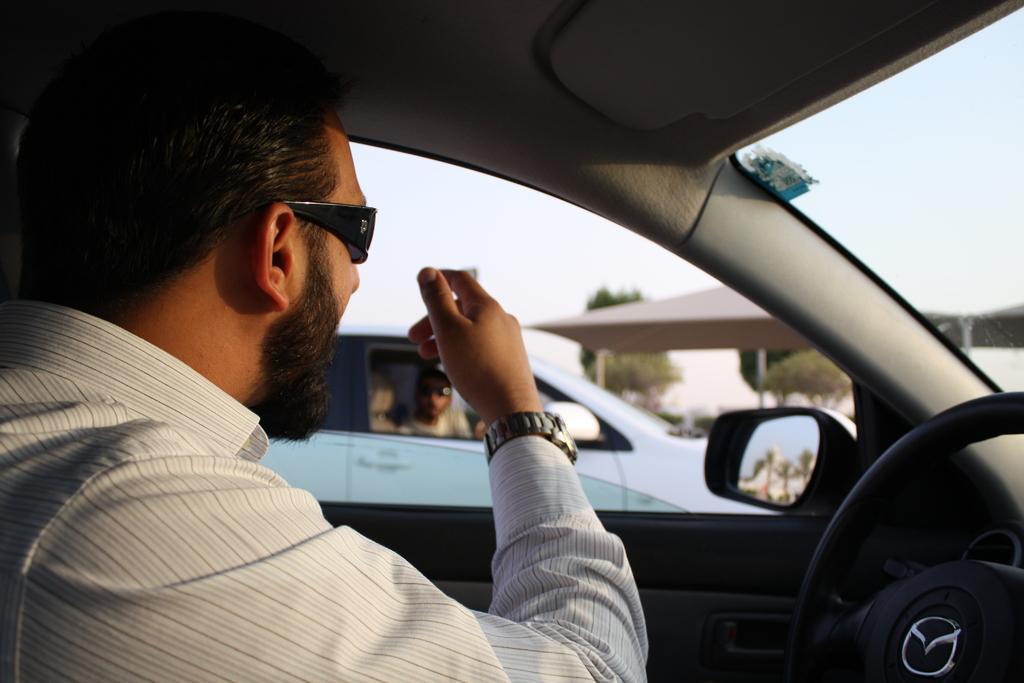Can you describe this image briefly? In the image there is a guy sat in a car, It seems to be on outside on road and beside the car there is another car with a guy. On steering there is mazda logo on it and above its sky. 